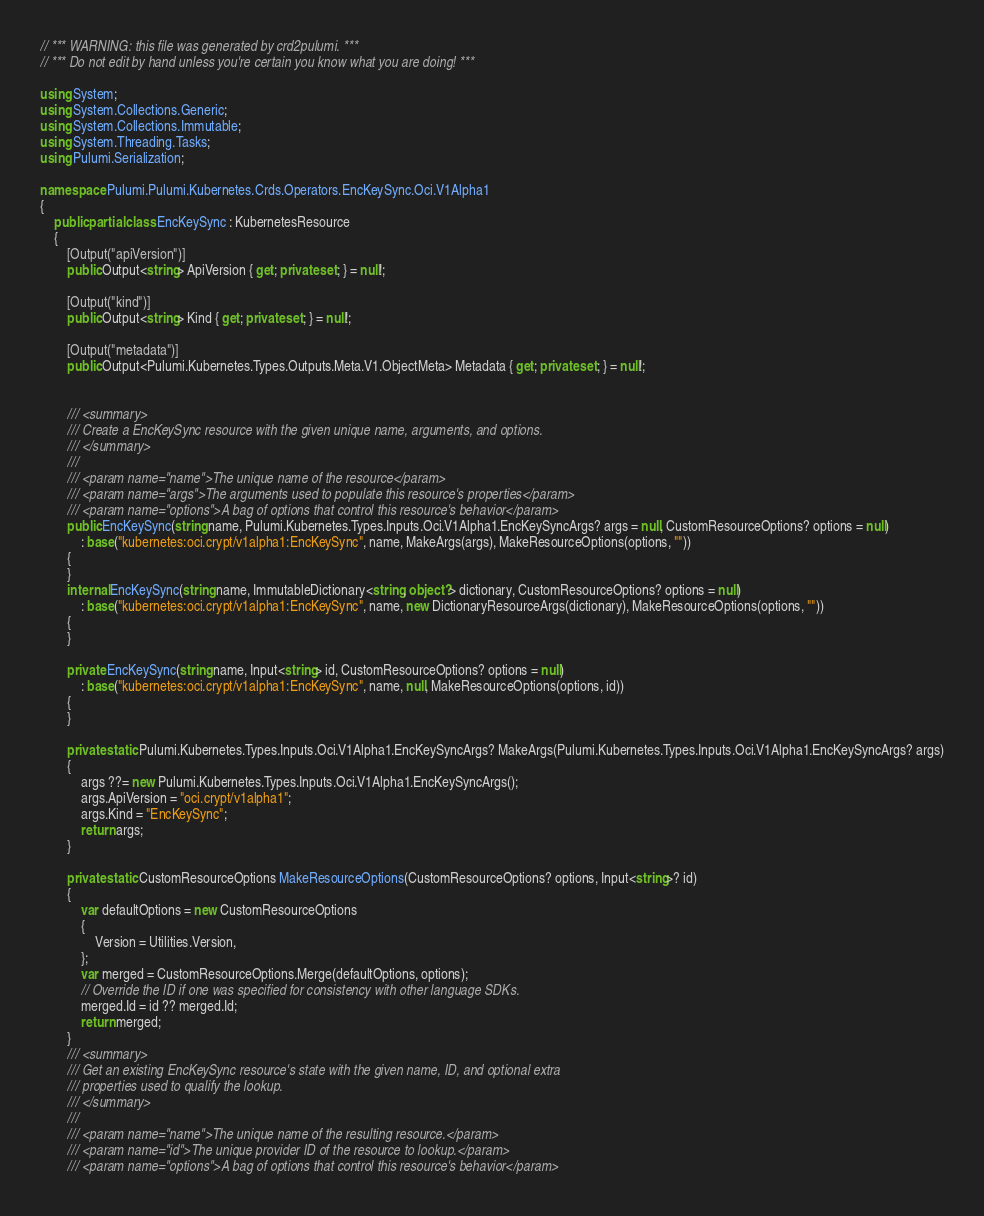<code> <loc_0><loc_0><loc_500><loc_500><_C#_>// *** WARNING: this file was generated by crd2pulumi. ***
// *** Do not edit by hand unless you're certain you know what you are doing! ***

using System;
using System.Collections.Generic;
using System.Collections.Immutable;
using System.Threading.Tasks;
using Pulumi.Serialization;

namespace Pulumi.Pulumi.Kubernetes.Crds.Operators.EncKeySync.Oci.V1Alpha1
{
    public partial class EncKeySync : KubernetesResource
    {
        [Output("apiVersion")]
        public Output<string> ApiVersion { get; private set; } = null!;

        [Output("kind")]
        public Output<string> Kind { get; private set; } = null!;

        [Output("metadata")]
        public Output<Pulumi.Kubernetes.Types.Outputs.Meta.V1.ObjectMeta> Metadata { get; private set; } = null!;


        /// <summary>
        /// Create a EncKeySync resource with the given unique name, arguments, and options.
        /// </summary>
        ///
        /// <param name="name">The unique name of the resource</param>
        /// <param name="args">The arguments used to populate this resource's properties</param>
        /// <param name="options">A bag of options that control this resource's behavior</param>
        public EncKeySync(string name, Pulumi.Kubernetes.Types.Inputs.Oci.V1Alpha1.EncKeySyncArgs? args = null, CustomResourceOptions? options = null)
            : base("kubernetes:oci.crypt/v1alpha1:EncKeySync", name, MakeArgs(args), MakeResourceOptions(options, ""))
        {
        }
        internal EncKeySync(string name, ImmutableDictionary<string, object?> dictionary, CustomResourceOptions? options = null)
            : base("kubernetes:oci.crypt/v1alpha1:EncKeySync", name, new DictionaryResourceArgs(dictionary), MakeResourceOptions(options, ""))
        {
        }

        private EncKeySync(string name, Input<string> id, CustomResourceOptions? options = null)
            : base("kubernetes:oci.crypt/v1alpha1:EncKeySync", name, null, MakeResourceOptions(options, id))
        {
        }

        private static Pulumi.Kubernetes.Types.Inputs.Oci.V1Alpha1.EncKeySyncArgs? MakeArgs(Pulumi.Kubernetes.Types.Inputs.Oci.V1Alpha1.EncKeySyncArgs? args)
        {
            args ??= new Pulumi.Kubernetes.Types.Inputs.Oci.V1Alpha1.EncKeySyncArgs();
            args.ApiVersion = "oci.crypt/v1alpha1";
            args.Kind = "EncKeySync";
            return args;
        }

        private static CustomResourceOptions MakeResourceOptions(CustomResourceOptions? options, Input<string>? id)
        {
            var defaultOptions = new CustomResourceOptions
            {
                Version = Utilities.Version,
            };
            var merged = CustomResourceOptions.Merge(defaultOptions, options);
            // Override the ID if one was specified for consistency with other language SDKs.
            merged.Id = id ?? merged.Id;
            return merged;
        }
        /// <summary>
        /// Get an existing EncKeySync resource's state with the given name, ID, and optional extra
        /// properties used to qualify the lookup.
        /// </summary>
        ///
        /// <param name="name">The unique name of the resulting resource.</param>
        /// <param name="id">The unique provider ID of the resource to lookup.</param>
        /// <param name="options">A bag of options that control this resource's behavior</param></code> 